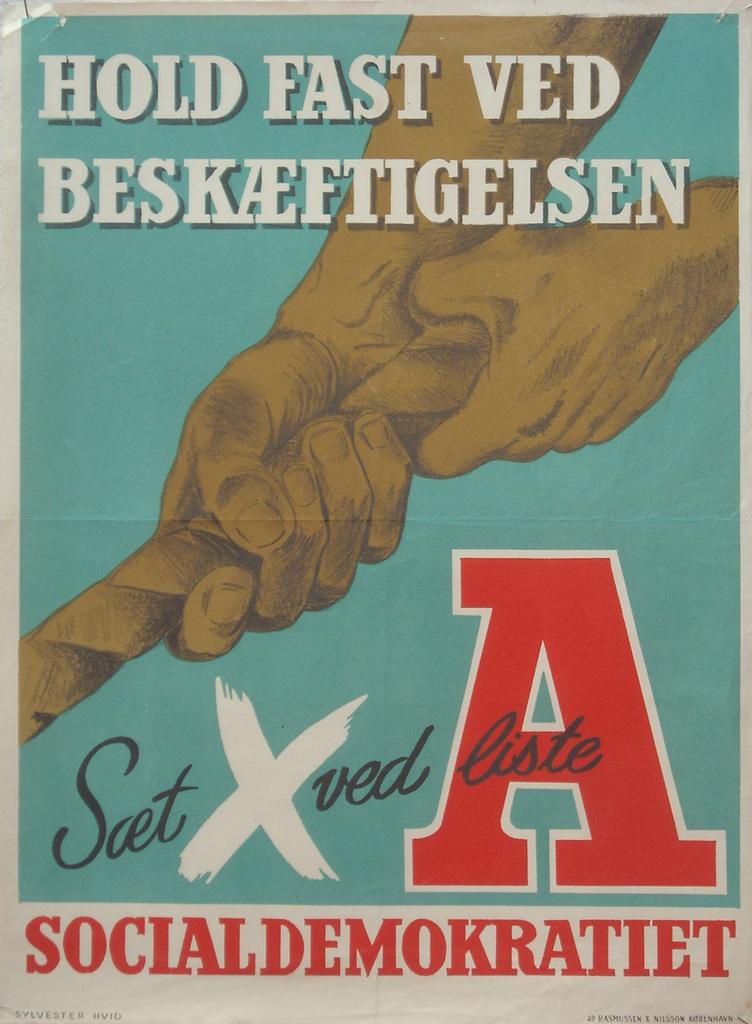What do you need to do fast?
Keep it short and to the point. Hold. What letter is large and in red?
Ensure brevity in your answer.  A. 